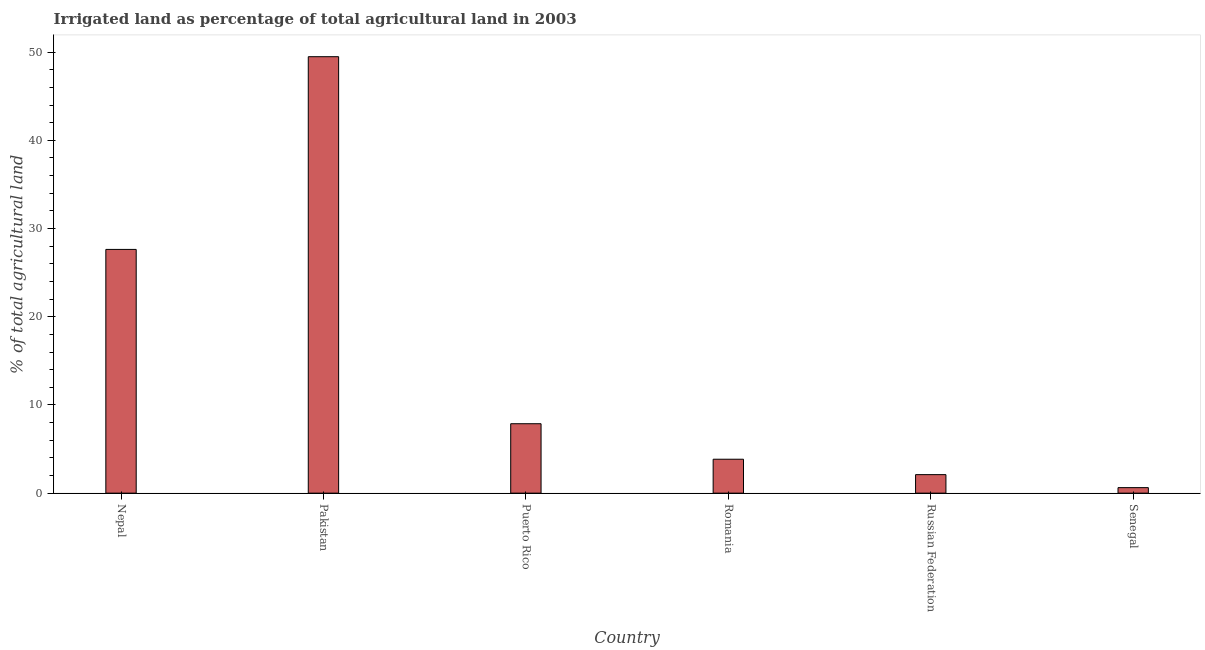Does the graph contain grids?
Provide a succinct answer. No. What is the title of the graph?
Keep it short and to the point. Irrigated land as percentage of total agricultural land in 2003. What is the label or title of the Y-axis?
Give a very brief answer. % of total agricultural land. What is the percentage of agricultural irrigated land in Puerto Rico?
Give a very brief answer. 7.87. Across all countries, what is the maximum percentage of agricultural irrigated land?
Your answer should be compact. 49.48. Across all countries, what is the minimum percentage of agricultural irrigated land?
Offer a terse response. 0.63. In which country was the percentage of agricultural irrigated land minimum?
Provide a short and direct response. Senegal. What is the sum of the percentage of agricultural irrigated land?
Ensure brevity in your answer.  91.55. What is the difference between the percentage of agricultural irrigated land in Pakistan and Puerto Rico?
Offer a very short reply. 41.61. What is the average percentage of agricultural irrigated land per country?
Ensure brevity in your answer.  15.26. What is the median percentage of agricultural irrigated land?
Make the answer very short. 5.86. In how many countries, is the percentage of agricultural irrigated land greater than 38 %?
Provide a succinct answer. 1. What is the ratio of the percentage of agricultural irrigated land in Romania to that in Senegal?
Your answer should be very brief. 6.15. Is the percentage of agricultural irrigated land in Nepal less than that in Pakistan?
Your answer should be very brief. Yes. Is the difference between the percentage of agricultural irrigated land in Romania and Senegal greater than the difference between any two countries?
Offer a very short reply. No. What is the difference between the highest and the second highest percentage of agricultural irrigated land?
Offer a terse response. 21.85. What is the difference between the highest and the lowest percentage of agricultural irrigated land?
Provide a short and direct response. 48.86. Are all the bars in the graph horizontal?
Give a very brief answer. No. How many countries are there in the graph?
Ensure brevity in your answer.  6. Are the values on the major ticks of Y-axis written in scientific E-notation?
Give a very brief answer. No. What is the % of total agricultural land of Nepal?
Your response must be concise. 27.63. What is the % of total agricultural land in Pakistan?
Ensure brevity in your answer.  49.48. What is the % of total agricultural land in Puerto Rico?
Your answer should be very brief. 7.87. What is the % of total agricultural land in Romania?
Ensure brevity in your answer.  3.84. What is the % of total agricultural land in Russian Federation?
Give a very brief answer. 2.1. What is the % of total agricultural land in Senegal?
Offer a very short reply. 0.63. What is the difference between the % of total agricultural land in Nepal and Pakistan?
Provide a succinct answer. -21.85. What is the difference between the % of total agricultural land in Nepal and Puerto Rico?
Your answer should be compact. 19.76. What is the difference between the % of total agricultural land in Nepal and Romania?
Your answer should be compact. 23.79. What is the difference between the % of total agricultural land in Nepal and Russian Federation?
Your response must be concise. 25.53. What is the difference between the % of total agricultural land in Nepal and Senegal?
Offer a very short reply. 27.01. What is the difference between the % of total agricultural land in Pakistan and Puerto Rico?
Your response must be concise. 41.61. What is the difference between the % of total agricultural land in Pakistan and Romania?
Your response must be concise. 45.64. What is the difference between the % of total agricultural land in Pakistan and Russian Federation?
Make the answer very short. 47.38. What is the difference between the % of total agricultural land in Pakistan and Senegal?
Your answer should be very brief. 48.86. What is the difference between the % of total agricultural land in Puerto Rico and Romania?
Offer a terse response. 4.03. What is the difference between the % of total agricultural land in Puerto Rico and Russian Federation?
Provide a succinct answer. 5.77. What is the difference between the % of total agricultural land in Puerto Rico and Senegal?
Ensure brevity in your answer.  7.24. What is the difference between the % of total agricultural land in Romania and Russian Federation?
Give a very brief answer. 1.74. What is the difference between the % of total agricultural land in Romania and Senegal?
Your answer should be compact. 3.22. What is the difference between the % of total agricultural land in Russian Federation and Senegal?
Offer a very short reply. 1.47. What is the ratio of the % of total agricultural land in Nepal to that in Pakistan?
Provide a short and direct response. 0.56. What is the ratio of the % of total agricultural land in Nepal to that in Puerto Rico?
Your answer should be very brief. 3.51. What is the ratio of the % of total agricultural land in Nepal to that in Romania?
Provide a short and direct response. 7.19. What is the ratio of the % of total agricultural land in Nepal to that in Russian Federation?
Your response must be concise. 13.16. What is the ratio of the % of total agricultural land in Nepal to that in Senegal?
Your response must be concise. 44.17. What is the ratio of the % of total agricultural land in Pakistan to that in Puerto Rico?
Keep it short and to the point. 6.29. What is the ratio of the % of total agricultural land in Pakistan to that in Romania?
Ensure brevity in your answer.  12.87. What is the ratio of the % of total agricultural land in Pakistan to that in Russian Federation?
Your answer should be compact. 23.57. What is the ratio of the % of total agricultural land in Pakistan to that in Senegal?
Offer a very short reply. 79.1. What is the ratio of the % of total agricultural land in Puerto Rico to that in Romania?
Ensure brevity in your answer.  2.05. What is the ratio of the % of total agricultural land in Puerto Rico to that in Russian Federation?
Ensure brevity in your answer.  3.75. What is the ratio of the % of total agricultural land in Puerto Rico to that in Senegal?
Ensure brevity in your answer.  12.58. What is the ratio of the % of total agricultural land in Romania to that in Russian Federation?
Your answer should be very brief. 1.83. What is the ratio of the % of total agricultural land in Romania to that in Senegal?
Offer a very short reply. 6.15. What is the ratio of the % of total agricultural land in Russian Federation to that in Senegal?
Offer a terse response. 3.36. 